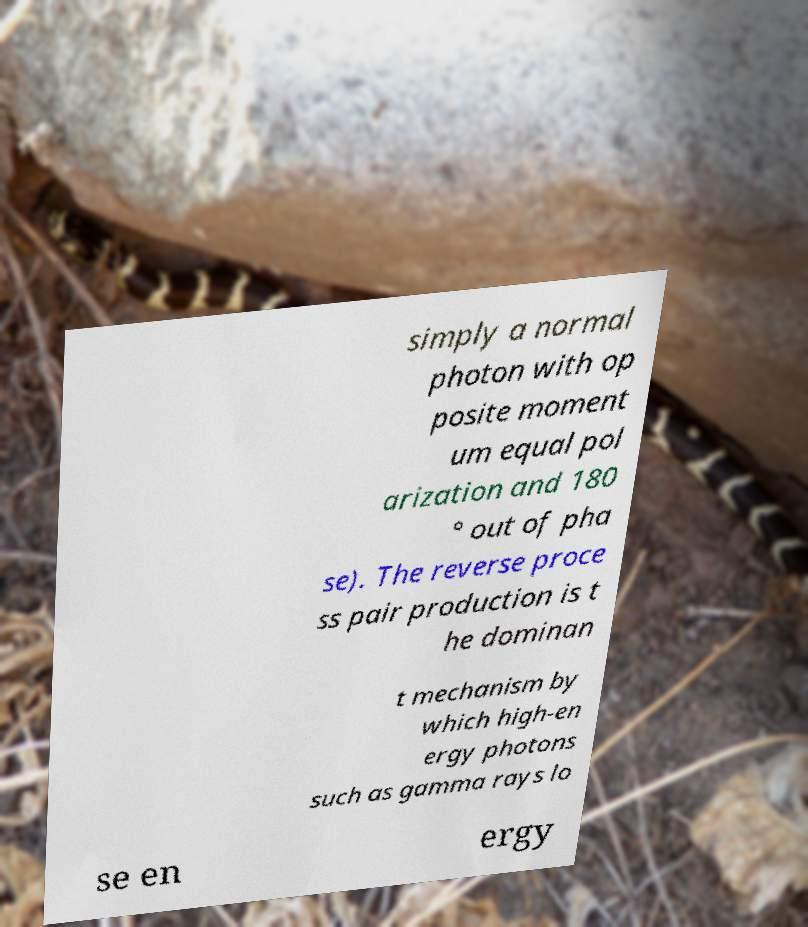I need the written content from this picture converted into text. Can you do that? simply a normal photon with op posite moment um equal pol arization and 180 ° out of pha se). The reverse proce ss pair production is t he dominan t mechanism by which high-en ergy photons such as gamma rays lo se en ergy 